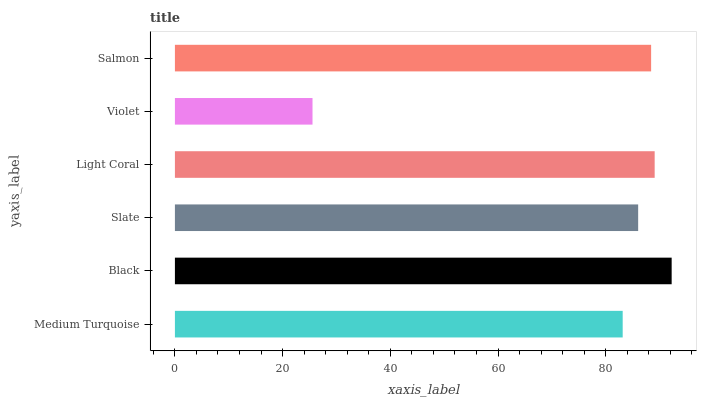Is Violet the minimum?
Answer yes or no. Yes. Is Black the maximum?
Answer yes or no. Yes. Is Slate the minimum?
Answer yes or no. No. Is Slate the maximum?
Answer yes or no. No. Is Black greater than Slate?
Answer yes or no. Yes. Is Slate less than Black?
Answer yes or no. Yes. Is Slate greater than Black?
Answer yes or no. No. Is Black less than Slate?
Answer yes or no. No. Is Salmon the high median?
Answer yes or no. Yes. Is Slate the low median?
Answer yes or no. Yes. Is Black the high median?
Answer yes or no. No. Is Salmon the low median?
Answer yes or no. No. 